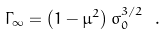<formula> <loc_0><loc_0><loc_500><loc_500>\Gamma _ { \infty } = \left ( 1 - \mu ^ { 2 } \right ) \sigma _ { 0 } ^ { 3 / 2 } \ .</formula> 